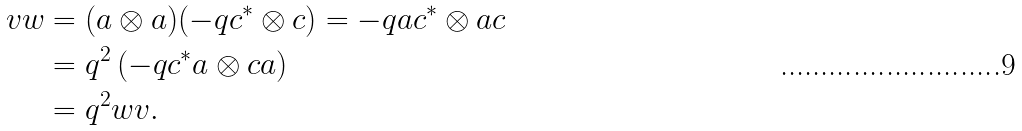Convert formula to latex. <formula><loc_0><loc_0><loc_500><loc_500>v w & = ( a \otimes a ) ( - q c ^ { * } \otimes c ) = - q a c ^ { * } \otimes a c \\ & = q ^ { 2 } \left ( - q c ^ { * } a \otimes c a \right ) \\ & = q ^ { 2 } w v .</formula> 